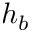<formula> <loc_0><loc_0><loc_500><loc_500>h _ { b }</formula> 